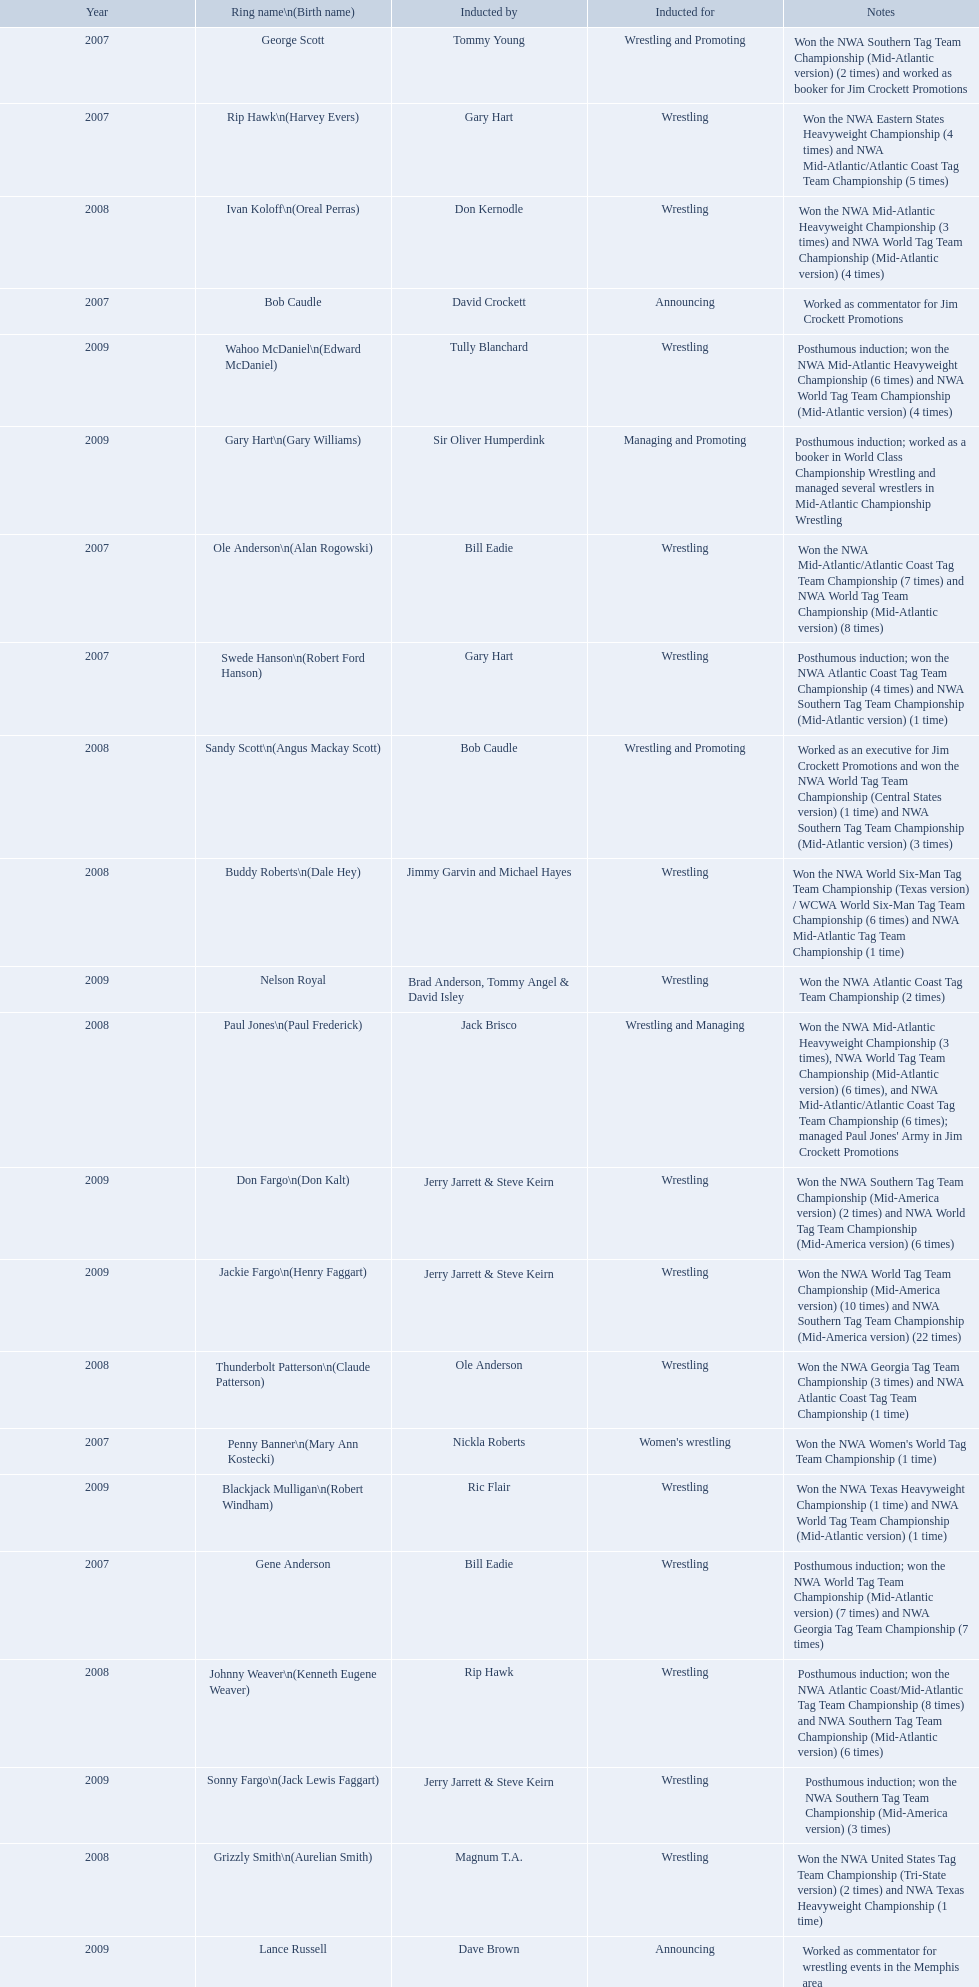Find the word(s) posthumous in the notes column. Posthumous induction; won the NWA World Tag Team Championship (Mid-Atlantic version) (7 times) and NWA Georgia Tag Team Championship (7 times), Posthumous induction; won the NWA Atlantic Coast Tag Team Championship (4 times) and NWA Southern Tag Team Championship (Mid-Atlantic version) (1 time), Posthumous induction; won the NWA Atlantic Coast/Mid-Atlantic Tag Team Championship (8 times) and NWA Southern Tag Team Championship (Mid-Atlantic version) (6 times), Posthumous induction; won the NWA Southern Tag Team Championship (Mid-America version) (3 times), Posthumous induction; worked as a booker in World Class Championship Wrestling and managed several wrestlers in Mid-Atlantic Championship Wrestling, Posthumous induction; won the NWA Mid-Atlantic Heavyweight Championship (6 times) and NWA World Tag Team Championship (Mid-Atlantic version) (4 times). What is the earliest year in the table that wrestlers were inducted? 2007, 2007, 2007, 2007, 2007, 2007, 2007. Find the wrestlers that wrestled underneath their birth name in the earliest year of induction. Gene Anderson, Bob Caudle, George Scott. Of the wrestlers who wrestled underneath their birth name in the earliest year of induction was one of them inducted posthumously? Gene Anderson. What were all the wrestler's ring names? Gene Anderson, Ole Anderson\n(Alan Rogowski), Penny Banner\n(Mary Ann Kostecki), Bob Caudle, Swede Hanson\n(Robert Ford Hanson), Rip Hawk\n(Harvey Evers), George Scott, Paul Jones\n(Paul Frederick), Ivan Koloff\n(Oreal Perras), Thunderbolt Patterson\n(Claude Patterson), Buddy Roberts\n(Dale Hey), Sandy Scott\n(Angus Mackay Scott), Grizzly Smith\n(Aurelian Smith), Johnny Weaver\n(Kenneth Eugene Weaver), Don Fargo\n(Don Kalt), Jackie Fargo\n(Henry Faggart), Sonny Fargo\n(Jack Lewis Faggart), Gary Hart\n(Gary Williams), Wahoo McDaniel\n(Edward McDaniel), Blackjack Mulligan\n(Robert Windham), Nelson Royal, Lance Russell. Besides bob caudle, who was an announcer? Lance Russell. Could you parse the entire table? {'header': ['Year', 'Ring name\\n(Birth name)', 'Inducted by', 'Inducted for', 'Notes'], 'rows': [['2007', 'George Scott', 'Tommy Young', 'Wrestling and Promoting', 'Won the NWA Southern Tag Team Championship (Mid-Atlantic version) (2 times) and worked as booker for Jim Crockett Promotions'], ['2007', 'Rip Hawk\\n(Harvey Evers)', 'Gary Hart', 'Wrestling', 'Won the NWA Eastern States Heavyweight Championship (4 times) and NWA Mid-Atlantic/Atlantic Coast Tag Team Championship (5 times)'], ['2008', 'Ivan Koloff\\n(Oreal Perras)', 'Don Kernodle', 'Wrestling', 'Won the NWA Mid-Atlantic Heavyweight Championship (3 times) and NWA World Tag Team Championship (Mid-Atlantic version) (4 times)'], ['2007', 'Bob Caudle', 'David Crockett', 'Announcing', 'Worked as commentator for Jim Crockett Promotions'], ['2009', 'Wahoo McDaniel\\n(Edward McDaniel)', 'Tully Blanchard', 'Wrestling', 'Posthumous induction; won the NWA Mid-Atlantic Heavyweight Championship (6 times) and NWA World Tag Team Championship (Mid-Atlantic version) (4 times)'], ['2009', 'Gary Hart\\n(Gary Williams)', 'Sir Oliver Humperdink', 'Managing and Promoting', 'Posthumous induction; worked as a booker in World Class Championship Wrestling and managed several wrestlers in Mid-Atlantic Championship Wrestling'], ['2007', 'Ole Anderson\\n(Alan Rogowski)', 'Bill Eadie', 'Wrestling', 'Won the NWA Mid-Atlantic/Atlantic Coast Tag Team Championship (7 times) and NWA World Tag Team Championship (Mid-Atlantic version) (8 times)'], ['2007', 'Swede Hanson\\n(Robert Ford Hanson)', 'Gary Hart', 'Wrestling', 'Posthumous induction; won the NWA Atlantic Coast Tag Team Championship (4 times) and NWA Southern Tag Team Championship (Mid-Atlantic version) (1 time)'], ['2008', 'Sandy Scott\\n(Angus Mackay Scott)', 'Bob Caudle', 'Wrestling and Promoting', 'Worked as an executive for Jim Crockett Promotions and won the NWA World Tag Team Championship (Central States version) (1 time) and NWA Southern Tag Team Championship (Mid-Atlantic version) (3 times)'], ['2008', 'Buddy Roberts\\n(Dale Hey)', 'Jimmy Garvin and Michael Hayes', 'Wrestling', 'Won the NWA World Six-Man Tag Team Championship (Texas version) / WCWA World Six-Man Tag Team Championship (6 times) and NWA Mid-Atlantic Tag Team Championship (1 time)'], ['2009', 'Nelson Royal', 'Brad Anderson, Tommy Angel & David Isley', 'Wrestling', 'Won the NWA Atlantic Coast Tag Team Championship (2 times)'], ['2008', 'Paul Jones\\n(Paul Frederick)', 'Jack Brisco', 'Wrestling and Managing', "Won the NWA Mid-Atlantic Heavyweight Championship (3 times), NWA World Tag Team Championship (Mid-Atlantic version) (6 times), and NWA Mid-Atlantic/Atlantic Coast Tag Team Championship (6 times); managed Paul Jones' Army in Jim Crockett Promotions"], ['2009', 'Don Fargo\\n(Don Kalt)', 'Jerry Jarrett & Steve Keirn', 'Wrestling', 'Won the NWA Southern Tag Team Championship (Mid-America version) (2 times) and NWA World Tag Team Championship (Mid-America version) (6 times)'], ['2009', 'Jackie Fargo\\n(Henry Faggart)', 'Jerry Jarrett & Steve Keirn', 'Wrestling', 'Won the NWA World Tag Team Championship (Mid-America version) (10 times) and NWA Southern Tag Team Championship (Mid-America version) (22 times)'], ['2008', 'Thunderbolt Patterson\\n(Claude Patterson)', 'Ole Anderson', 'Wrestling', 'Won the NWA Georgia Tag Team Championship (3 times) and NWA Atlantic Coast Tag Team Championship (1 time)'], ['2007', 'Penny Banner\\n(Mary Ann Kostecki)', 'Nickla Roberts', "Women's wrestling", "Won the NWA Women's World Tag Team Championship (1 time)"], ['2009', 'Blackjack Mulligan\\n(Robert Windham)', 'Ric Flair', 'Wrestling', 'Won the NWA Texas Heavyweight Championship (1 time) and NWA World Tag Team Championship (Mid-Atlantic version) (1 time)'], ['2007', 'Gene Anderson', 'Bill Eadie', 'Wrestling', 'Posthumous induction; won the NWA World Tag Team Championship (Mid-Atlantic version) (7 times) and NWA Georgia Tag Team Championship (7 times)'], ['2008', 'Johnny Weaver\\n(Kenneth Eugene Weaver)', 'Rip Hawk', 'Wrestling', 'Posthumous induction; won the NWA Atlantic Coast/Mid-Atlantic Tag Team Championship (8 times) and NWA Southern Tag Team Championship (Mid-Atlantic version) (6 times)'], ['2009', 'Sonny Fargo\\n(Jack Lewis Faggart)', 'Jerry Jarrett & Steve Keirn', 'Wrestling', 'Posthumous induction; won the NWA Southern Tag Team Championship (Mid-America version) (3 times)'], ['2008', 'Grizzly Smith\\n(Aurelian Smith)', 'Magnum T.A.', 'Wrestling', 'Won the NWA United States Tag Team Championship (Tri-State version) (2 times) and NWA Texas Heavyweight Championship (1 time)'], ['2009', 'Lance Russell', 'Dave Brown', 'Announcing', 'Worked as commentator for wrestling events in the Memphis area']]} What announcers were inducted? Bob Caudle, Lance Russell. What announcer was inducted in 2009? Lance Russell. 